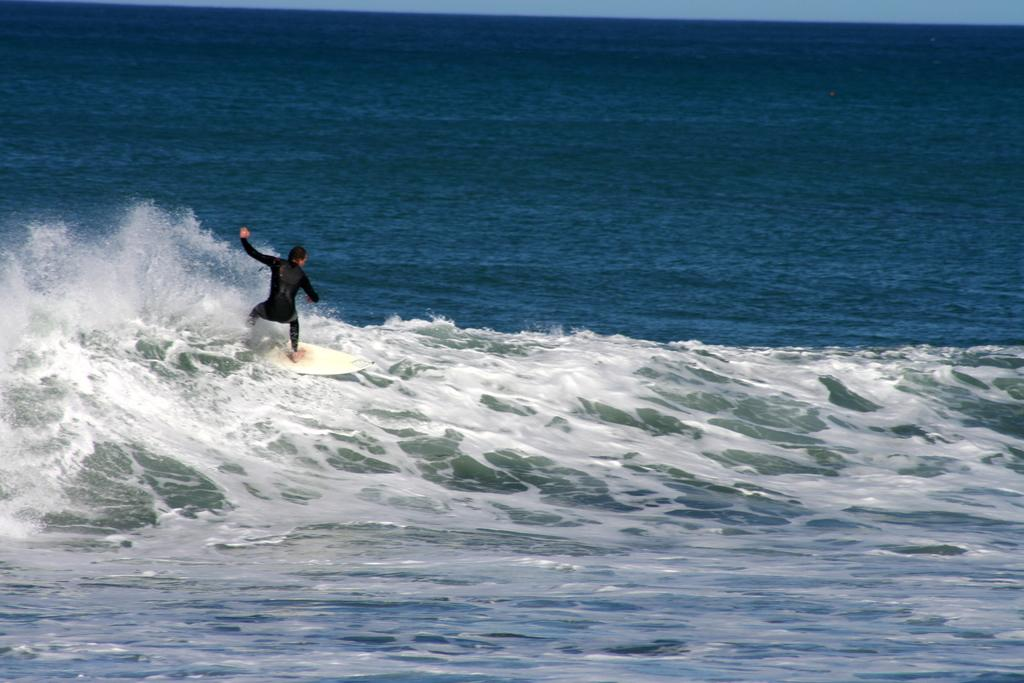What is the person in the image doing? The person is surfing in water. What object is the person using to surf? The person is using a surfboard. What color is the surfboard? The surfboard is white. What is the person wearing while surfing? The person is wearing a black dress. Can you see any zephyrs in the image? There is no mention of zephyrs in the image, as it features a person surfing on a white surfboard while wearing a black dress. 